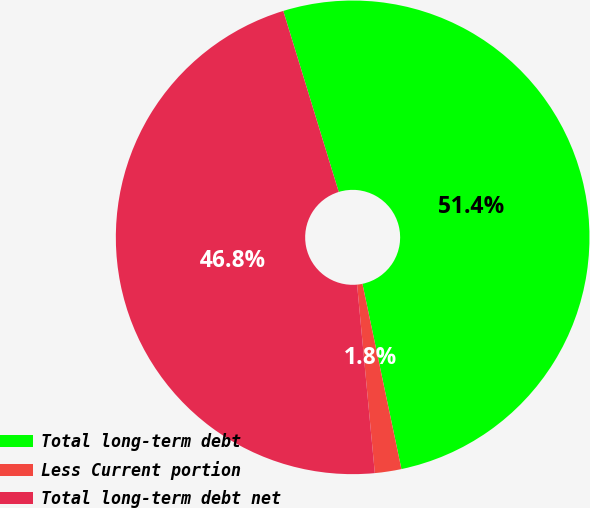<chart> <loc_0><loc_0><loc_500><loc_500><pie_chart><fcel>Total long-term debt<fcel>Less Current portion<fcel>Total long-term debt net<nl><fcel>51.43%<fcel>1.81%<fcel>46.76%<nl></chart> 